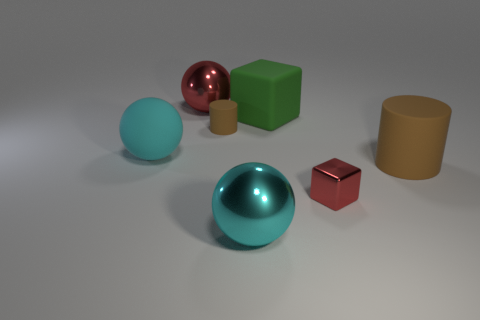The tiny cube has what color?
Provide a succinct answer. Red. There is a tiny cylinder that is the same color as the large cylinder; what material is it?
Give a very brief answer. Rubber. Is there another red thing that has the same shape as the tiny red object?
Provide a short and direct response. No. There is a cyan sphere on the left side of the red sphere; what size is it?
Your response must be concise. Large. What material is the red sphere that is the same size as the matte block?
Your response must be concise. Metal. Is the number of large purple blocks greater than the number of small red objects?
Offer a terse response. No. What size is the red metal thing that is right of the large shiny object in front of the green object?
Give a very brief answer. Small. The green matte object that is the same size as the cyan shiny object is what shape?
Make the answer very short. Cube. The small thing to the right of the ball that is in front of the matte thing that is in front of the cyan matte thing is what shape?
Ensure brevity in your answer.  Cube. There is a metal ball that is behind the large cyan metal ball; is it the same color as the tiny cylinder to the left of the large green thing?
Your response must be concise. No. 